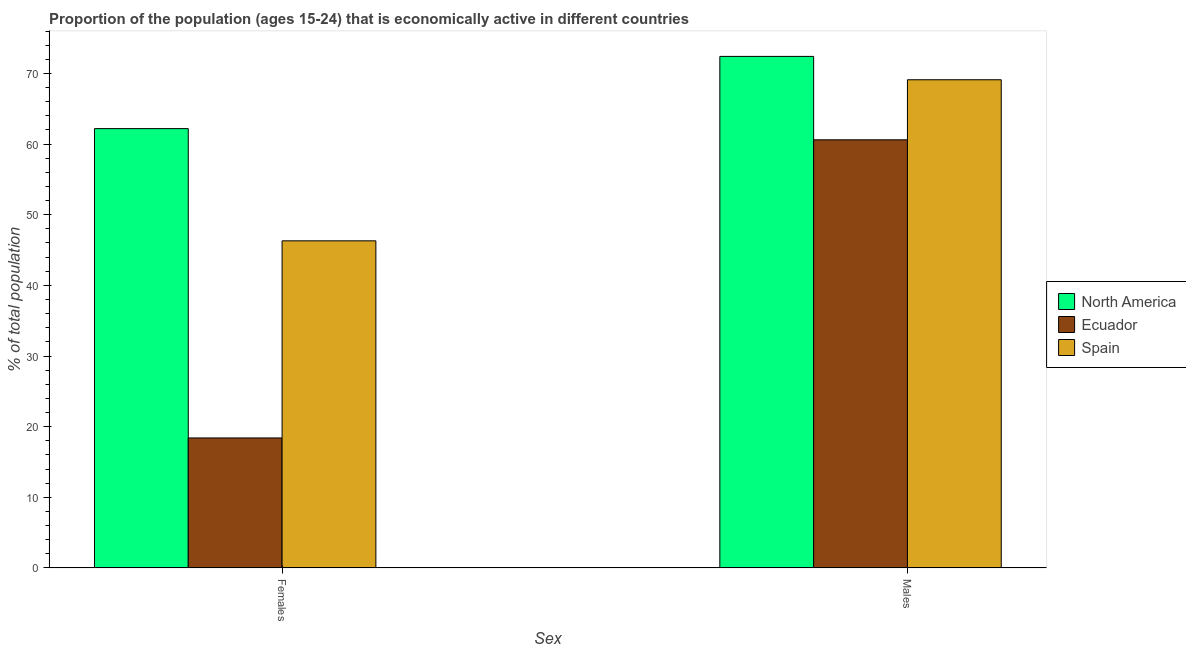How many groups of bars are there?
Your answer should be very brief. 2. Are the number of bars per tick equal to the number of legend labels?
Ensure brevity in your answer.  Yes. Are the number of bars on each tick of the X-axis equal?
Your response must be concise. Yes. How many bars are there on the 1st tick from the left?
Give a very brief answer. 3. What is the label of the 1st group of bars from the left?
Your answer should be compact. Females. What is the percentage of economically active male population in Spain?
Provide a succinct answer. 69.1. Across all countries, what is the maximum percentage of economically active male population?
Ensure brevity in your answer.  72.41. Across all countries, what is the minimum percentage of economically active female population?
Offer a terse response. 18.4. In which country was the percentage of economically active male population maximum?
Your response must be concise. North America. In which country was the percentage of economically active female population minimum?
Offer a terse response. Ecuador. What is the total percentage of economically active male population in the graph?
Offer a terse response. 202.11. What is the difference between the percentage of economically active female population in Ecuador and that in Spain?
Your response must be concise. -27.9. What is the difference between the percentage of economically active male population in North America and the percentage of economically active female population in Ecuador?
Provide a short and direct response. 54.01. What is the average percentage of economically active male population per country?
Make the answer very short. 67.37. What is the difference between the percentage of economically active female population and percentage of economically active male population in Spain?
Offer a terse response. -22.8. What is the ratio of the percentage of economically active female population in Ecuador to that in North America?
Keep it short and to the point. 0.3. Is the percentage of economically active male population in Ecuador less than that in North America?
Provide a short and direct response. Yes. What does the 2nd bar from the left in Males represents?
Provide a short and direct response. Ecuador. What does the 2nd bar from the right in Females represents?
Give a very brief answer. Ecuador. How many bars are there?
Provide a succinct answer. 6. How many countries are there in the graph?
Offer a terse response. 3. What is the difference between two consecutive major ticks on the Y-axis?
Make the answer very short. 10. Does the graph contain any zero values?
Give a very brief answer. No. Does the graph contain grids?
Give a very brief answer. No. Where does the legend appear in the graph?
Make the answer very short. Center right. How many legend labels are there?
Your response must be concise. 3. How are the legend labels stacked?
Your response must be concise. Vertical. What is the title of the graph?
Make the answer very short. Proportion of the population (ages 15-24) that is economically active in different countries. Does "Latvia" appear as one of the legend labels in the graph?
Your answer should be very brief. No. What is the label or title of the X-axis?
Your answer should be compact. Sex. What is the label or title of the Y-axis?
Provide a succinct answer. % of total population. What is the % of total population in North America in Females?
Provide a succinct answer. 62.19. What is the % of total population in Ecuador in Females?
Your answer should be compact. 18.4. What is the % of total population in Spain in Females?
Provide a short and direct response. 46.3. What is the % of total population in North America in Males?
Keep it short and to the point. 72.41. What is the % of total population in Ecuador in Males?
Keep it short and to the point. 60.6. What is the % of total population in Spain in Males?
Ensure brevity in your answer.  69.1. Across all Sex, what is the maximum % of total population in North America?
Offer a terse response. 72.41. Across all Sex, what is the maximum % of total population of Ecuador?
Provide a short and direct response. 60.6. Across all Sex, what is the maximum % of total population of Spain?
Provide a succinct answer. 69.1. Across all Sex, what is the minimum % of total population of North America?
Provide a succinct answer. 62.19. Across all Sex, what is the minimum % of total population in Ecuador?
Make the answer very short. 18.4. Across all Sex, what is the minimum % of total population of Spain?
Your response must be concise. 46.3. What is the total % of total population in North America in the graph?
Give a very brief answer. 134.59. What is the total % of total population in Ecuador in the graph?
Provide a succinct answer. 79. What is the total % of total population in Spain in the graph?
Give a very brief answer. 115.4. What is the difference between the % of total population in North America in Females and that in Males?
Your answer should be very brief. -10.22. What is the difference between the % of total population in Ecuador in Females and that in Males?
Give a very brief answer. -42.2. What is the difference between the % of total population of Spain in Females and that in Males?
Provide a succinct answer. -22.8. What is the difference between the % of total population of North America in Females and the % of total population of Ecuador in Males?
Offer a very short reply. 1.59. What is the difference between the % of total population of North America in Females and the % of total population of Spain in Males?
Offer a terse response. -6.91. What is the difference between the % of total population of Ecuador in Females and the % of total population of Spain in Males?
Provide a short and direct response. -50.7. What is the average % of total population of North America per Sex?
Provide a short and direct response. 67.3. What is the average % of total population of Ecuador per Sex?
Your answer should be compact. 39.5. What is the average % of total population in Spain per Sex?
Your answer should be very brief. 57.7. What is the difference between the % of total population of North America and % of total population of Ecuador in Females?
Your answer should be compact. 43.79. What is the difference between the % of total population in North America and % of total population in Spain in Females?
Your response must be concise. 15.89. What is the difference between the % of total population of Ecuador and % of total population of Spain in Females?
Keep it short and to the point. -27.9. What is the difference between the % of total population of North America and % of total population of Ecuador in Males?
Ensure brevity in your answer.  11.81. What is the difference between the % of total population in North America and % of total population in Spain in Males?
Give a very brief answer. 3.31. What is the difference between the % of total population of Ecuador and % of total population of Spain in Males?
Offer a terse response. -8.5. What is the ratio of the % of total population of North America in Females to that in Males?
Offer a very short reply. 0.86. What is the ratio of the % of total population of Ecuador in Females to that in Males?
Offer a terse response. 0.3. What is the ratio of the % of total population of Spain in Females to that in Males?
Ensure brevity in your answer.  0.67. What is the difference between the highest and the second highest % of total population in North America?
Provide a short and direct response. 10.22. What is the difference between the highest and the second highest % of total population of Ecuador?
Your response must be concise. 42.2. What is the difference between the highest and the second highest % of total population in Spain?
Your answer should be very brief. 22.8. What is the difference between the highest and the lowest % of total population of North America?
Make the answer very short. 10.22. What is the difference between the highest and the lowest % of total population of Ecuador?
Keep it short and to the point. 42.2. What is the difference between the highest and the lowest % of total population of Spain?
Your answer should be compact. 22.8. 